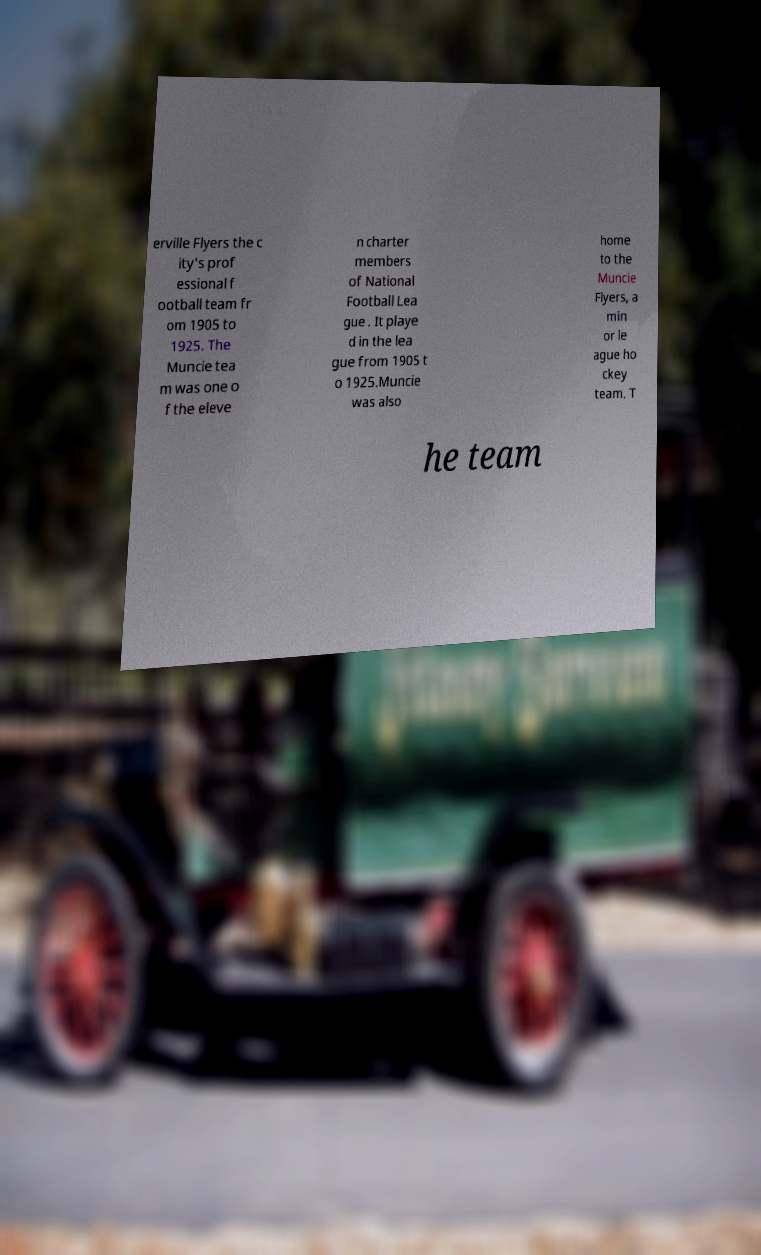Can you read and provide the text displayed in the image?This photo seems to have some interesting text. Can you extract and type it out for me? erville Flyers the c ity's prof essional f ootball team fr om 1905 to 1925. The Muncie tea m was one o f the eleve n charter members of National Football Lea gue . It playe d in the lea gue from 1905 t o 1925.Muncie was also home to the Muncie Flyers, a min or le ague ho ckey team. T he team 